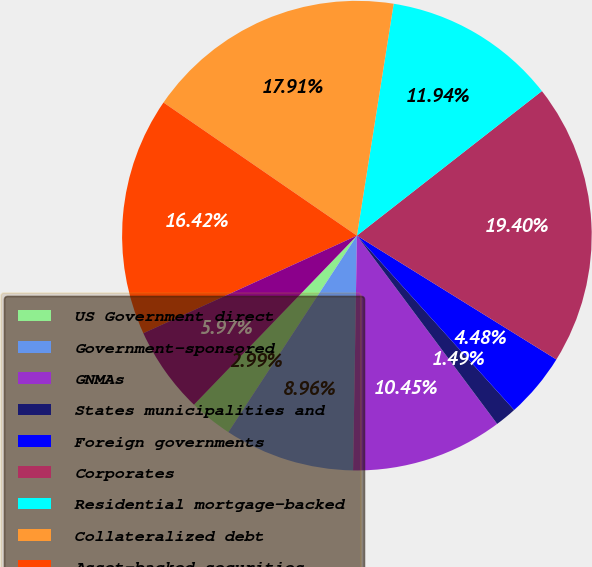Convert chart to OTSL. <chart><loc_0><loc_0><loc_500><loc_500><pie_chart><fcel>US Government direct<fcel>Government-sponsored<fcel>GNMAs<fcel>States municipalities and<fcel>Foreign governments<fcel>Corporates<fcel>Residential mortgage-backed<fcel>Collateralized debt<fcel>Asset-backed securities<fcel>Redeemable preferred stocks<nl><fcel>2.99%<fcel>8.96%<fcel>10.45%<fcel>1.49%<fcel>4.48%<fcel>19.4%<fcel>11.94%<fcel>17.91%<fcel>16.42%<fcel>5.97%<nl></chart> 